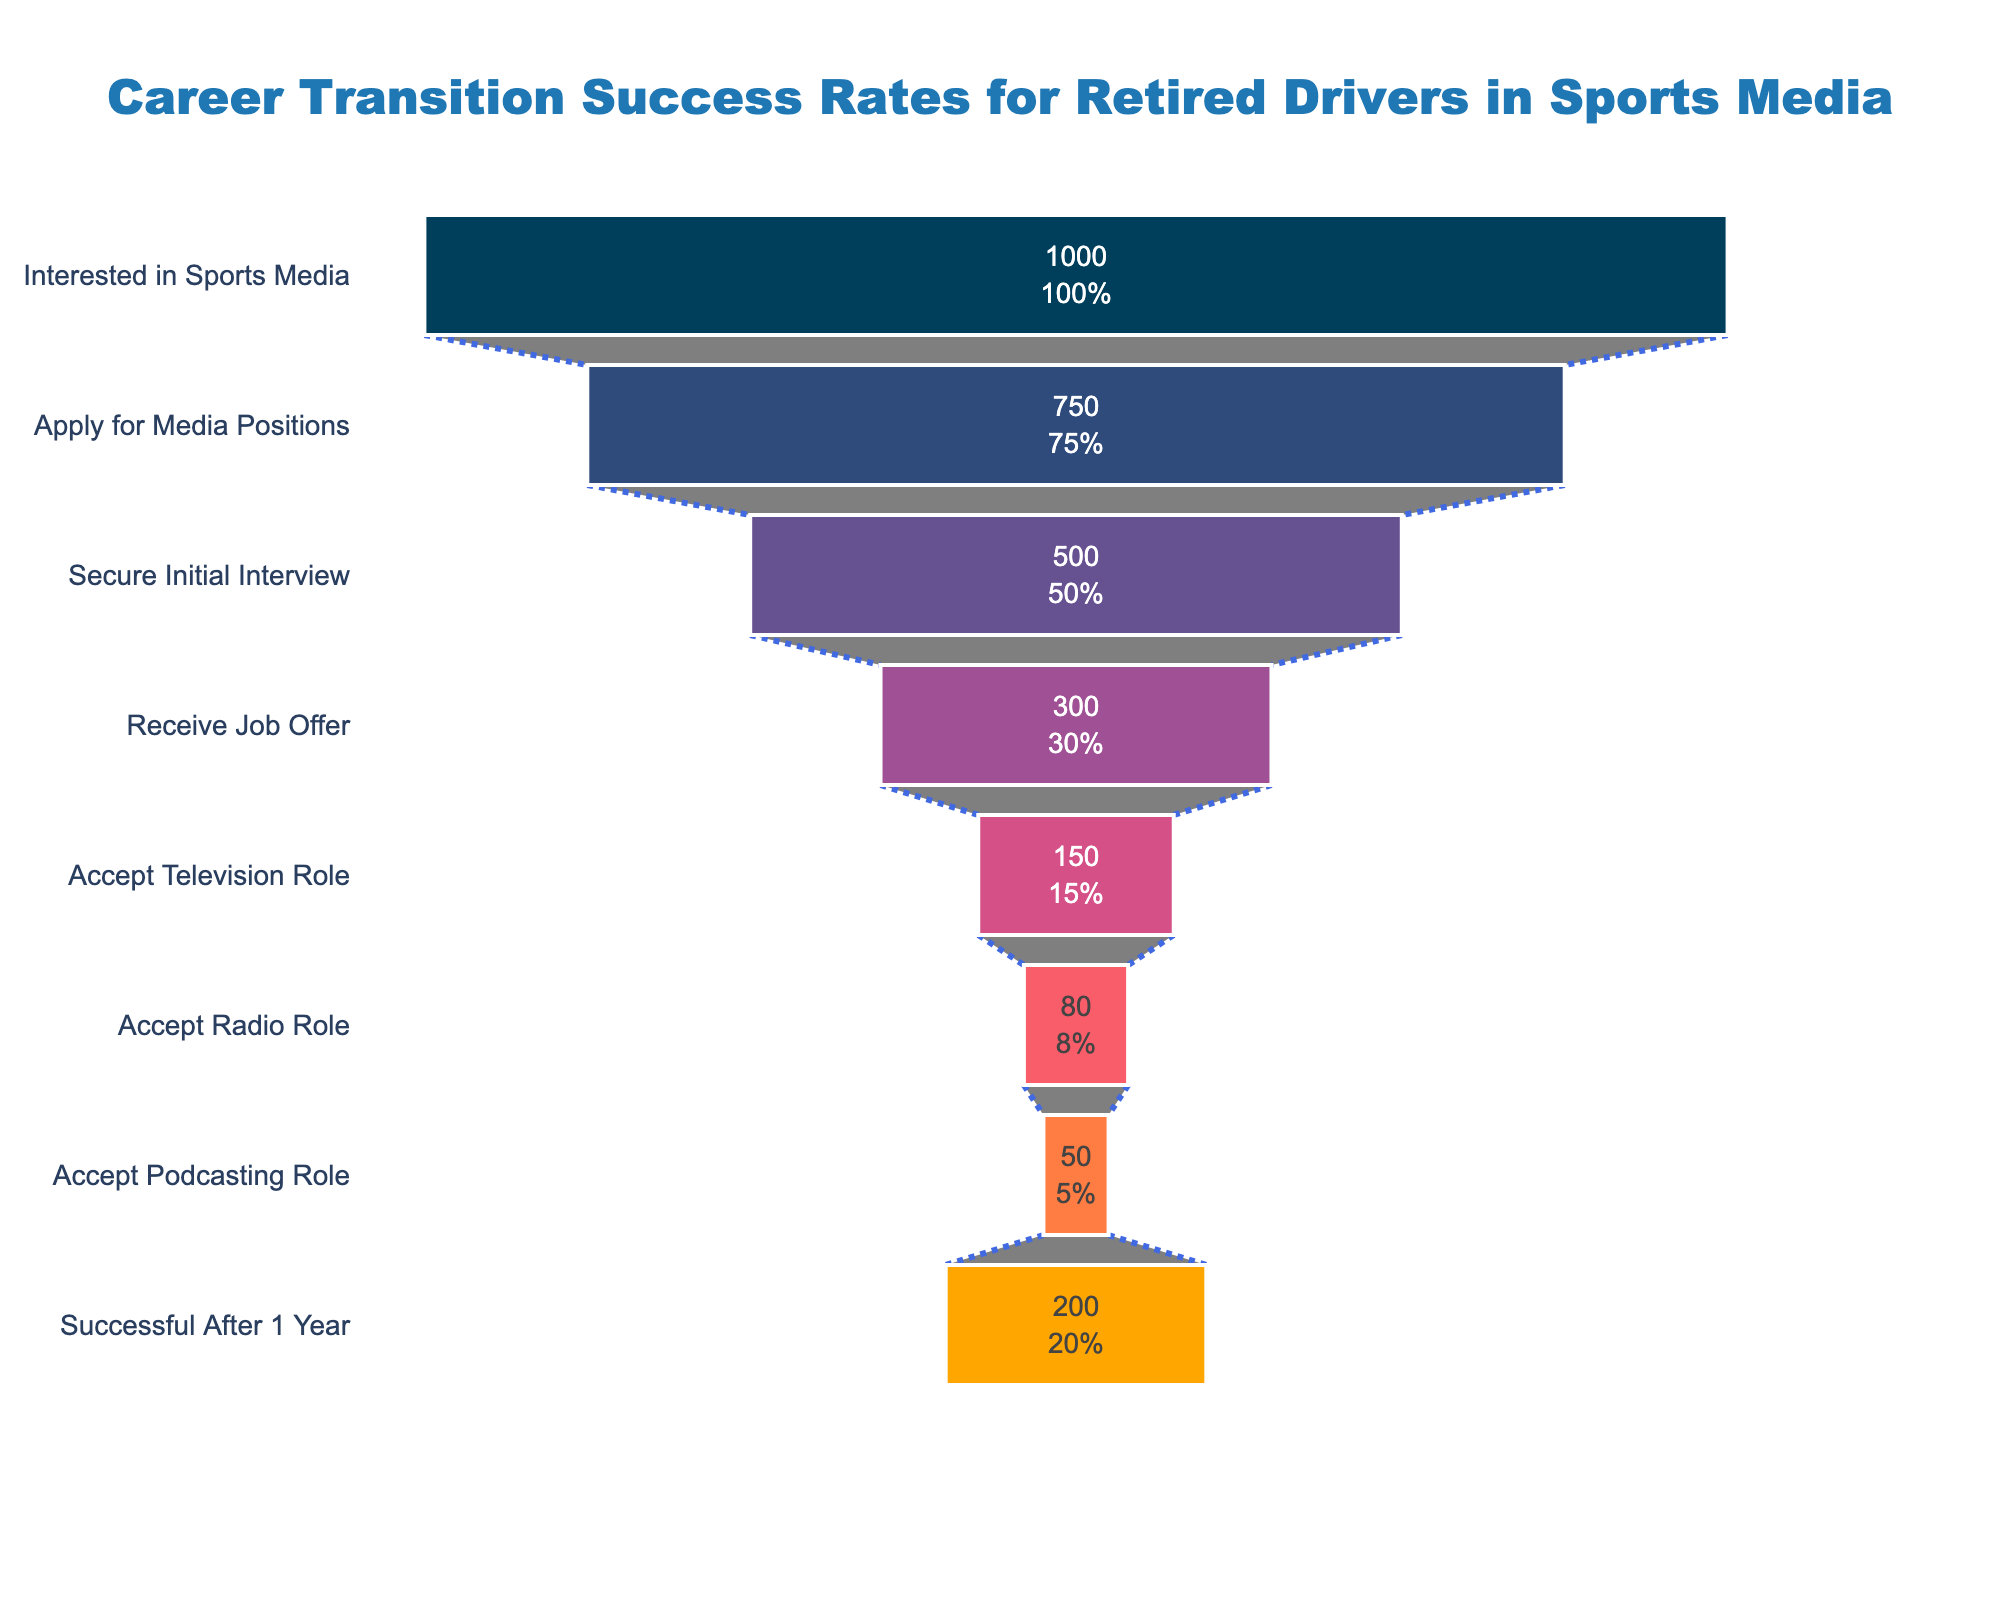What's the title of this funnel chart? The title of the funnel chart is displayed at the top of the image. It is in a larger font with a distinct color which makes it easily readable.
Answer: Career Transition Success Rates for Retired Drivers in Sports Media How many retired drivers secured an initial interview out of those who applied for media positions? We can see from the funnel chart that the number of retired drivers who secured an initial interview is clearly labeled in the middle of the chart, directly corresponding to this stage.
Answer: 500 What percentage of retired drivers interested in sports media receive a job offer? The percentage can be derived from the values in the funnel chart. We see that 300 drivers received a job offer out of 1000 interested drivers. The percentage is calculated as (300/1000) * 100.
Answer: 30% How many retired drivers who received a job offer accepted roles in television, radio, and podcasting combined? To find the total, we need to sum the number of drivers who accepted roles in each of the three sectors: television (150), radio (80), and podcasting (50).
Answer: 280 Which media sector has the lowest number of retired drivers accepting roles, and how many drivers is that? The number of retired drivers who accepted roles in the different media sectors is listed in the funnel chart. We compare the three values: television (150), radio (80), podcasting (50).
Answer: Podcasting, 50 What is the difference in the number of retired drivers who secure an initial interview versus those who accept podcasting roles? We need to subtract the number of drivers who accepted podcasting roles (50) from those who secured an initial interview (500).
Answer: 450 What proportion of retired drivers who accept television roles are successful after one year? The number of retired drivers who accept television roles is 150, and those who are successful after one year is 200. To find the proportion of television role accepters within the successful category, divide 150 by 200.
Answer: 0.75 What is the total number of retired drivers who accepted any type of media role and were successful after one year? Since there are no overlapping categories, we use the total number of drivers successful after one year as the total number who accepted roles and were successful: 200.
Answer: 200 